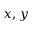<formula> <loc_0><loc_0><loc_500><loc_500>x , y</formula> 